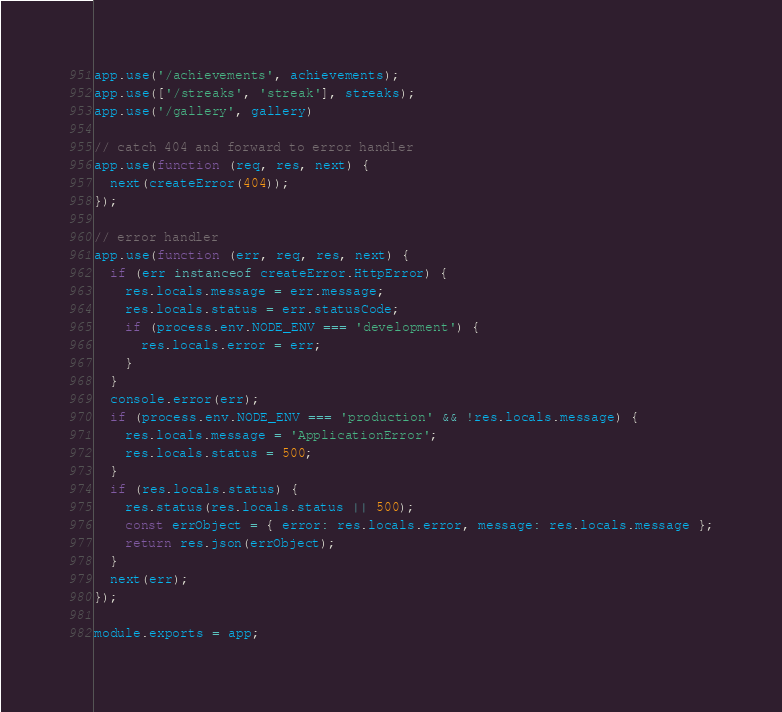Convert code to text. <code><loc_0><loc_0><loc_500><loc_500><_JavaScript_>app.use('/achievements', achievements);
app.use(['/streaks', 'streak'], streaks);
app.use('/gallery', gallery)

// catch 404 and forward to error handler
app.use(function (req, res, next) {
  next(createError(404));
});

// error handler
app.use(function (err, req, res, next) {
  if (err instanceof createError.HttpError) {
    res.locals.message = err.message;
    res.locals.status = err.statusCode;
    if (process.env.NODE_ENV === 'development') {
      res.locals.error = err;
    }
  }
  console.error(err);
  if (process.env.NODE_ENV === 'production' && !res.locals.message) {
    res.locals.message = 'ApplicationError';
    res.locals.status = 500;
  }
  if (res.locals.status) {
    res.status(res.locals.status || 500);
    const errObject = { error: res.locals.error, message: res.locals.message };
    return res.json(errObject);
  }
  next(err);
});

module.exports = app;
</code> 